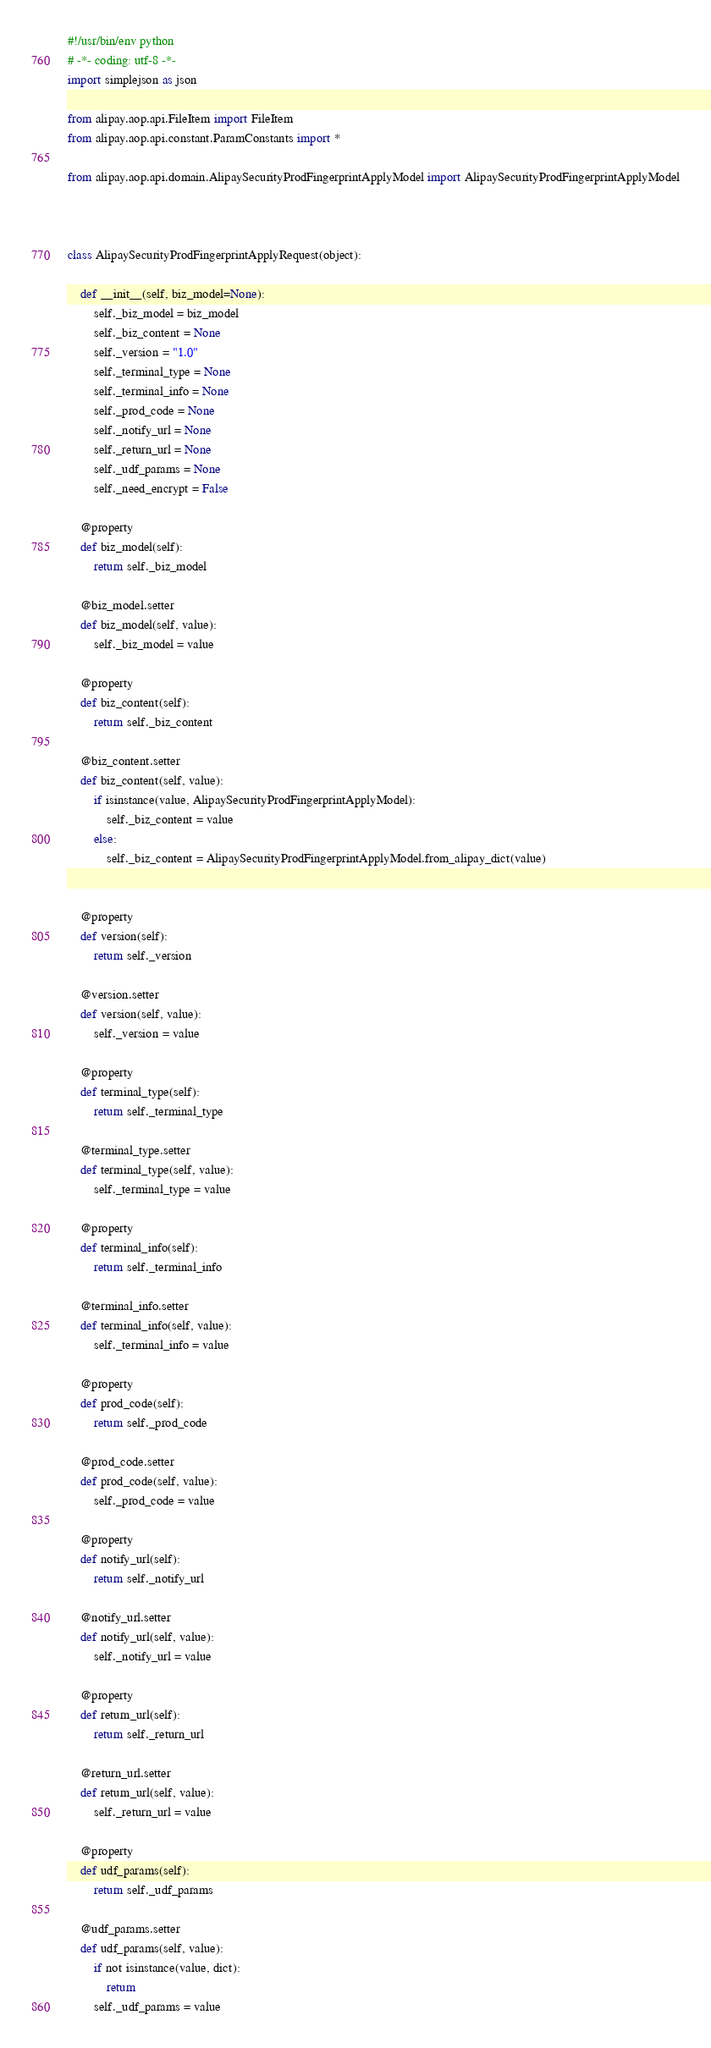<code> <loc_0><loc_0><loc_500><loc_500><_Python_>#!/usr/bin/env python
# -*- coding: utf-8 -*-
import simplejson as json

from alipay.aop.api.FileItem import FileItem
from alipay.aop.api.constant.ParamConstants import *

from alipay.aop.api.domain.AlipaySecurityProdFingerprintApplyModel import AlipaySecurityProdFingerprintApplyModel



class AlipaySecurityProdFingerprintApplyRequest(object):

    def __init__(self, biz_model=None):
        self._biz_model = biz_model
        self._biz_content = None
        self._version = "1.0"
        self._terminal_type = None
        self._terminal_info = None
        self._prod_code = None
        self._notify_url = None
        self._return_url = None
        self._udf_params = None
        self._need_encrypt = False

    @property
    def biz_model(self):
        return self._biz_model

    @biz_model.setter
    def biz_model(self, value):
        self._biz_model = value

    @property
    def biz_content(self):
        return self._biz_content

    @biz_content.setter
    def biz_content(self, value):
        if isinstance(value, AlipaySecurityProdFingerprintApplyModel):
            self._biz_content = value
        else:
            self._biz_content = AlipaySecurityProdFingerprintApplyModel.from_alipay_dict(value)


    @property
    def version(self):
        return self._version

    @version.setter
    def version(self, value):
        self._version = value

    @property
    def terminal_type(self):
        return self._terminal_type

    @terminal_type.setter
    def terminal_type(self, value):
        self._terminal_type = value

    @property
    def terminal_info(self):
        return self._terminal_info

    @terminal_info.setter
    def terminal_info(self, value):
        self._terminal_info = value

    @property
    def prod_code(self):
        return self._prod_code

    @prod_code.setter
    def prod_code(self, value):
        self._prod_code = value

    @property
    def notify_url(self):
        return self._notify_url

    @notify_url.setter
    def notify_url(self, value):
        self._notify_url = value

    @property
    def return_url(self):
        return self._return_url

    @return_url.setter
    def return_url(self, value):
        self._return_url = value

    @property
    def udf_params(self):
        return self._udf_params

    @udf_params.setter
    def udf_params(self, value):
        if not isinstance(value, dict):
            return
        self._udf_params = value
</code> 